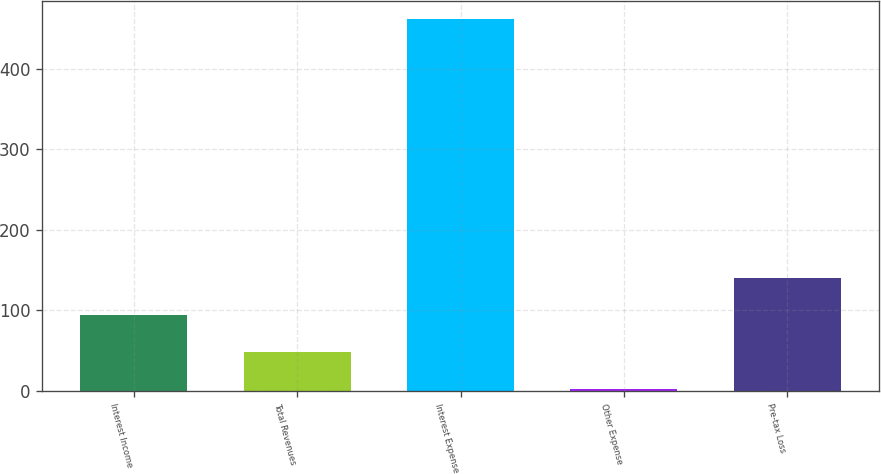<chart> <loc_0><loc_0><loc_500><loc_500><bar_chart><fcel>Interest Income<fcel>Total Revenues<fcel>Interest Expense<fcel>Other Expense<fcel>Pre-tax Loss<nl><fcel>94<fcel>48<fcel>462<fcel>2<fcel>140<nl></chart> 